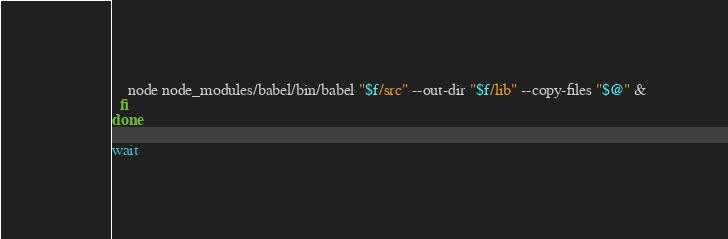<code> <loc_0><loc_0><loc_500><loc_500><_Bash_>    node node_modules/babel/bin/babel "$f/src" --out-dir "$f/lib" --copy-files "$@" &
  fi
done

wait
</code> 